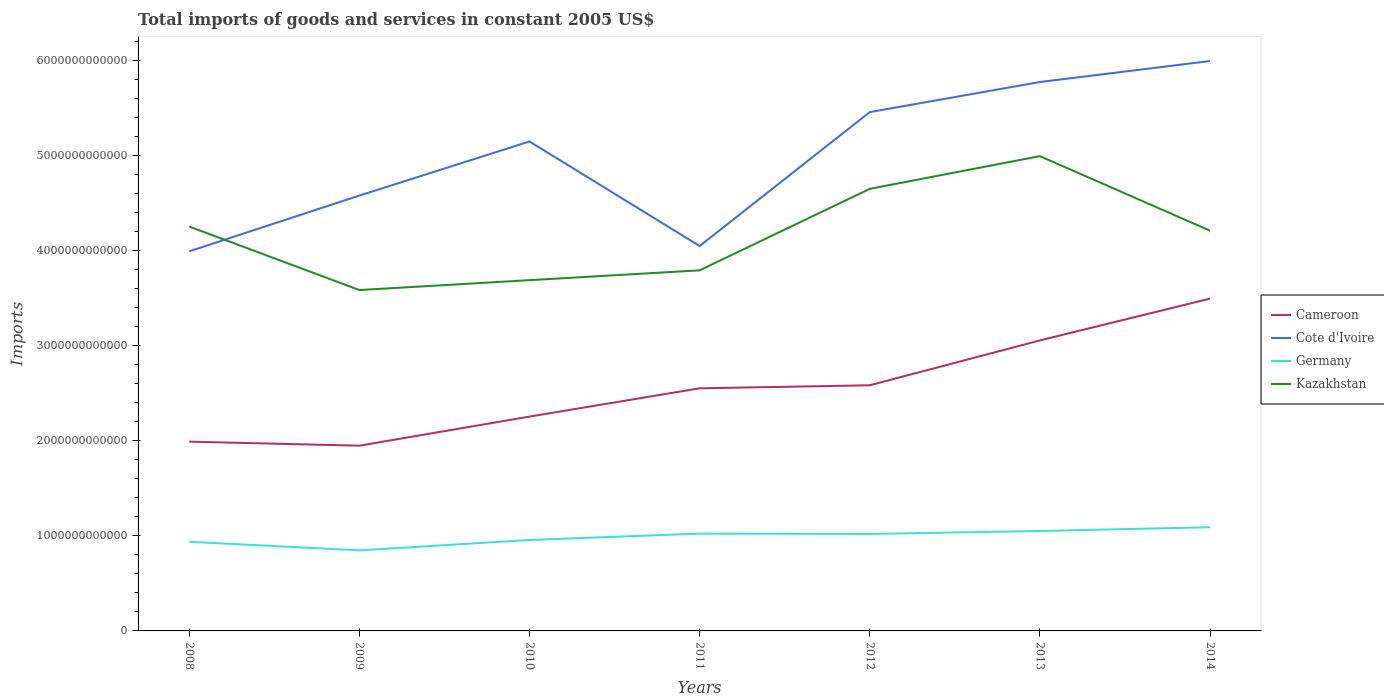Does the line corresponding to Cameroon intersect with the line corresponding to Germany?
Ensure brevity in your answer.  No. Across all years, what is the maximum total imports of goods and services in Kazakhstan?
Keep it short and to the point. 3.58e+12. In which year was the total imports of goods and services in Germany maximum?
Provide a short and direct response. 2009. What is the total total imports of goods and services in Cameroon in the graph?
Your answer should be very brief. -4.39e+11. What is the difference between the highest and the second highest total imports of goods and services in Cameroon?
Provide a succinct answer. 1.55e+12. How many years are there in the graph?
Your answer should be very brief. 7. What is the difference between two consecutive major ticks on the Y-axis?
Keep it short and to the point. 1.00e+12. Are the values on the major ticks of Y-axis written in scientific E-notation?
Your answer should be very brief. No. Does the graph contain any zero values?
Keep it short and to the point. No. Where does the legend appear in the graph?
Your answer should be very brief. Center right. How many legend labels are there?
Your answer should be compact. 4. What is the title of the graph?
Provide a succinct answer. Total imports of goods and services in constant 2005 US$. What is the label or title of the Y-axis?
Offer a terse response. Imports. What is the Imports in Cameroon in 2008?
Your response must be concise. 1.99e+12. What is the Imports in Cote d'Ivoire in 2008?
Offer a terse response. 3.99e+12. What is the Imports in Germany in 2008?
Provide a short and direct response. 9.37e+11. What is the Imports in Kazakhstan in 2008?
Keep it short and to the point. 4.25e+12. What is the Imports in Cameroon in 2009?
Your response must be concise. 1.95e+12. What is the Imports of Cote d'Ivoire in 2009?
Provide a succinct answer. 4.58e+12. What is the Imports of Germany in 2009?
Offer a very short reply. 8.47e+11. What is the Imports in Kazakhstan in 2009?
Ensure brevity in your answer.  3.58e+12. What is the Imports in Cameroon in 2010?
Provide a short and direct response. 2.25e+12. What is the Imports in Cote d'Ivoire in 2010?
Your response must be concise. 5.15e+12. What is the Imports in Germany in 2010?
Your answer should be compact. 9.56e+11. What is the Imports of Kazakhstan in 2010?
Provide a succinct answer. 3.69e+12. What is the Imports in Cameroon in 2011?
Keep it short and to the point. 2.55e+12. What is the Imports of Cote d'Ivoire in 2011?
Make the answer very short. 4.05e+12. What is the Imports in Germany in 2011?
Keep it short and to the point. 1.02e+12. What is the Imports in Kazakhstan in 2011?
Your response must be concise. 3.79e+12. What is the Imports of Cameroon in 2012?
Your answer should be very brief. 2.58e+12. What is the Imports in Cote d'Ivoire in 2012?
Your response must be concise. 5.45e+12. What is the Imports in Germany in 2012?
Provide a succinct answer. 1.02e+12. What is the Imports of Kazakhstan in 2012?
Ensure brevity in your answer.  4.65e+12. What is the Imports in Cameroon in 2013?
Your answer should be compact. 3.05e+12. What is the Imports in Cote d'Ivoire in 2013?
Make the answer very short. 5.77e+12. What is the Imports of Germany in 2013?
Your answer should be very brief. 1.05e+12. What is the Imports in Kazakhstan in 2013?
Provide a short and direct response. 4.99e+12. What is the Imports of Cameroon in 2014?
Provide a succinct answer. 3.49e+12. What is the Imports of Cote d'Ivoire in 2014?
Ensure brevity in your answer.  5.99e+12. What is the Imports of Germany in 2014?
Your answer should be compact. 1.09e+12. What is the Imports in Kazakhstan in 2014?
Provide a short and direct response. 4.21e+12. Across all years, what is the maximum Imports in Cameroon?
Provide a short and direct response. 3.49e+12. Across all years, what is the maximum Imports of Cote d'Ivoire?
Give a very brief answer. 5.99e+12. Across all years, what is the maximum Imports in Germany?
Your answer should be compact. 1.09e+12. Across all years, what is the maximum Imports in Kazakhstan?
Provide a succinct answer. 4.99e+12. Across all years, what is the minimum Imports of Cameroon?
Offer a very short reply. 1.95e+12. Across all years, what is the minimum Imports of Cote d'Ivoire?
Offer a very short reply. 3.99e+12. Across all years, what is the minimum Imports of Germany?
Make the answer very short. 8.47e+11. Across all years, what is the minimum Imports in Kazakhstan?
Your answer should be very brief. 3.58e+12. What is the total Imports in Cameroon in the graph?
Give a very brief answer. 1.79e+13. What is the total Imports of Cote d'Ivoire in the graph?
Provide a short and direct response. 3.50e+13. What is the total Imports in Germany in the graph?
Keep it short and to the point. 6.92e+12. What is the total Imports of Kazakhstan in the graph?
Give a very brief answer. 2.92e+13. What is the difference between the Imports of Cameroon in 2008 and that in 2009?
Provide a succinct answer. 4.22e+1. What is the difference between the Imports in Cote d'Ivoire in 2008 and that in 2009?
Keep it short and to the point. -5.86e+11. What is the difference between the Imports in Germany in 2008 and that in 2009?
Make the answer very short. 9.00e+1. What is the difference between the Imports of Kazakhstan in 2008 and that in 2009?
Your answer should be compact. 6.67e+11. What is the difference between the Imports in Cameroon in 2008 and that in 2010?
Provide a short and direct response. -2.63e+11. What is the difference between the Imports in Cote d'Ivoire in 2008 and that in 2010?
Your answer should be very brief. -1.15e+12. What is the difference between the Imports in Germany in 2008 and that in 2010?
Make the answer very short. -1.89e+1. What is the difference between the Imports in Kazakhstan in 2008 and that in 2010?
Keep it short and to the point. 5.63e+11. What is the difference between the Imports of Cameroon in 2008 and that in 2011?
Provide a short and direct response. -5.61e+11. What is the difference between the Imports in Cote d'Ivoire in 2008 and that in 2011?
Provide a succinct answer. -5.56e+1. What is the difference between the Imports of Germany in 2008 and that in 2011?
Ensure brevity in your answer.  -8.60e+1. What is the difference between the Imports of Kazakhstan in 2008 and that in 2011?
Your response must be concise. 4.60e+11. What is the difference between the Imports in Cameroon in 2008 and that in 2012?
Your answer should be compact. -5.93e+11. What is the difference between the Imports in Cote d'Ivoire in 2008 and that in 2012?
Give a very brief answer. -1.46e+12. What is the difference between the Imports of Germany in 2008 and that in 2012?
Your answer should be very brief. -8.25e+1. What is the difference between the Imports of Kazakhstan in 2008 and that in 2012?
Offer a terse response. -3.96e+11. What is the difference between the Imports of Cameroon in 2008 and that in 2013?
Offer a terse response. -1.06e+12. What is the difference between the Imports in Cote d'Ivoire in 2008 and that in 2013?
Your answer should be very brief. -1.78e+12. What is the difference between the Imports in Germany in 2008 and that in 2013?
Make the answer very short. -1.14e+11. What is the difference between the Imports of Kazakhstan in 2008 and that in 2013?
Provide a succinct answer. -7.40e+11. What is the difference between the Imports in Cameroon in 2008 and that in 2014?
Provide a succinct answer. -1.50e+12. What is the difference between the Imports in Cote d'Ivoire in 2008 and that in 2014?
Your answer should be very brief. -2.00e+12. What is the difference between the Imports of Germany in 2008 and that in 2014?
Keep it short and to the point. -1.53e+11. What is the difference between the Imports of Kazakhstan in 2008 and that in 2014?
Your answer should be compact. 4.33e+1. What is the difference between the Imports in Cameroon in 2009 and that in 2010?
Your response must be concise. -3.06e+11. What is the difference between the Imports of Cote d'Ivoire in 2009 and that in 2010?
Provide a short and direct response. -5.69e+11. What is the difference between the Imports of Germany in 2009 and that in 2010?
Keep it short and to the point. -1.09e+11. What is the difference between the Imports of Kazakhstan in 2009 and that in 2010?
Offer a terse response. -1.04e+11. What is the difference between the Imports in Cameroon in 2009 and that in 2011?
Your answer should be very brief. -6.03e+11. What is the difference between the Imports of Cote d'Ivoire in 2009 and that in 2011?
Your answer should be very brief. 5.30e+11. What is the difference between the Imports of Germany in 2009 and that in 2011?
Keep it short and to the point. -1.76e+11. What is the difference between the Imports of Kazakhstan in 2009 and that in 2011?
Offer a very short reply. -2.07e+11. What is the difference between the Imports in Cameroon in 2009 and that in 2012?
Your answer should be very brief. -6.35e+11. What is the difference between the Imports of Cote d'Ivoire in 2009 and that in 2012?
Give a very brief answer. -8.78e+11. What is the difference between the Imports in Germany in 2009 and that in 2012?
Offer a very short reply. -1.72e+11. What is the difference between the Imports of Kazakhstan in 2009 and that in 2012?
Offer a terse response. -1.06e+12. What is the difference between the Imports in Cameroon in 2009 and that in 2013?
Provide a short and direct response. -1.11e+12. What is the difference between the Imports of Cote d'Ivoire in 2009 and that in 2013?
Your answer should be compact. -1.19e+12. What is the difference between the Imports of Germany in 2009 and that in 2013?
Offer a terse response. -2.04e+11. What is the difference between the Imports of Kazakhstan in 2009 and that in 2013?
Your answer should be compact. -1.41e+12. What is the difference between the Imports of Cameroon in 2009 and that in 2014?
Give a very brief answer. -1.55e+12. What is the difference between the Imports of Cote d'Ivoire in 2009 and that in 2014?
Your answer should be compact. -1.41e+12. What is the difference between the Imports of Germany in 2009 and that in 2014?
Your answer should be compact. -2.43e+11. What is the difference between the Imports of Kazakhstan in 2009 and that in 2014?
Give a very brief answer. -6.24e+11. What is the difference between the Imports in Cameroon in 2010 and that in 2011?
Keep it short and to the point. -2.97e+11. What is the difference between the Imports in Cote d'Ivoire in 2010 and that in 2011?
Provide a short and direct response. 1.10e+12. What is the difference between the Imports of Germany in 2010 and that in 2011?
Ensure brevity in your answer.  -6.71e+1. What is the difference between the Imports of Kazakhstan in 2010 and that in 2011?
Your answer should be very brief. -1.03e+11. What is the difference between the Imports in Cameroon in 2010 and that in 2012?
Ensure brevity in your answer.  -3.29e+11. What is the difference between the Imports of Cote d'Ivoire in 2010 and that in 2012?
Keep it short and to the point. -3.09e+11. What is the difference between the Imports of Germany in 2010 and that in 2012?
Provide a succinct answer. -6.36e+1. What is the difference between the Imports in Kazakhstan in 2010 and that in 2012?
Your answer should be very brief. -9.60e+11. What is the difference between the Imports in Cameroon in 2010 and that in 2013?
Your answer should be very brief. -8.01e+11. What is the difference between the Imports in Cote d'Ivoire in 2010 and that in 2013?
Offer a terse response. -6.25e+11. What is the difference between the Imports in Germany in 2010 and that in 2013?
Ensure brevity in your answer.  -9.48e+1. What is the difference between the Imports in Kazakhstan in 2010 and that in 2013?
Your answer should be very brief. -1.30e+12. What is the difference between the Imports of Cameroon in 2010 and that in 2014?
Give a very brief answer. -1.24e+12. What is the difference between the Imports of Cote d'Ivoire in 2010 and that in 2014?
Your answer should be very brief. -8.46e+11. What is the difference between the Imports of Germany in 2010 and that in 2014?
Offer a very short reply. -1.34e+11. What is the difference between the Imports in Kazakhstan in 2010 and that in 2014?
Make the answer very short. -5.20e+11. What is the difference between the Imports of Cameroon in 2011 and that in 2012?
Your answer should be compact. -3.18e+1. What is the difference between the Imports in Cote d'Ivoire in 2011 and that in 2012?
Give a very brief answer. -1.41e+12. What is the difference between the Imports in Germany in 2011 and that in 2012?
Provide a short and direct response. 3.54e+09. What is the difference between the Imports in Kazakhstan in 2011 and that in 2012?
Offer a terse response. -8.57e+11. What is the difference between the Imports in Cameroon in 2011 and that in 2013?
Make the answer very short. -5.04e+11. What is the difference between the Imports in Cote d'Ivoire in 2011 and that in 2013?
Make the answer very short. -1.72e+12. What is the difference between the Imports of Germany in 2011 and that in 2013?
Your response must be concise. -2.77e+1. What is the difference between the Imports in Kazakhstan in 2011 and that in 2013?
Offer a very short reply. -1.20e+12. What is the difference between the Imports of Cameroon in 2011 and that in 2014?
Your answer should be compact. -9.43e+11. What is the difference between the Imports in Cote d'Ivoire in 2011 and that in 2014?
Provide a short and direct response. -1.94e+12. What is the difference between the Imports of Germany in 2011 and that in 2014?
Make the answer very short. -6.69e+1. What is the difference between the Imports in Kazakhstan in 2011 and that in 2014?
Offer a very short reply. -4.17e+11. What is the difference between the Imports of Cameroon in 2012 and that in 2013?
Give a very brief answer. -4.72e+11. What is the difference between the Imports in Cote d'Ivoire in 2012 and that in 2013?
Give a very brief answer. -3.16e+11. What is the difference between the Imports of Germany in 2012 and that in 2013?
Your answer should be compact. -3.13e+1. What is the difference between the Imports in Kazakhstan in 2012 and that in 2013?
Your response must be concise. -3.44e+11. What is the difference between the Imports of Cameroon in 2012 and that in 2014?
Provide a succinct answer. -9.11e+11. What is the difference between the Imports in Cote d'Ivoire in 2012 and that in 2014?
Provide a succinct answer. -5.37e+11. What is the difference between the Imports in Germany in 2012 and that in 2014?
Keep it short and to the point. -7.05e+1. What is the difference between the Imports of Kazakhstan in 2012 and that in 2014?
Offer a very short reply. 4.40e+11. What is the difference between the Imports of Cameroon in 2013 and that in 2014?
Offer a terse response. -4.39e+11. What is the difference between the Imports of Cote d'Ivoire in 2013 and that in 2014?
Ensure brevity in your answer.  -2.21e+11. What is the difference between the Imports of Germany in 2013 and that in 2014?
Make the answer very short. -3.92e+1. What is the difference between the Imports of Kazakhstan in 2013 and that in 2014?
Make the answer very short. 7.84e+11. What is the difference between the Imports in Cameroon in 2008 and the Imports in Cote d'Ivoire in 2009?
Offer a terse response. -2.59e+12. What is the difference between the Imports in Cameroon in 2008 and the Imports in Germany in 2009?
Your answer should be very brief. 1.14e+12. What is the difference between the Imports of Cameroon in 2008 and the Imports of Kazakhstan in 2009?
Provide a short and direct response. -1.59e+12. What is the difference between the Imports of Cote d'Ivoire in 2008 and the Imports of Germany in 2009?
Your answer should be compact. 3.14e+12. What is the difference between the Imports in Cote d'Ivoire in 2008 and the Imports in Kazakhstan in 2009?
Keep it short and to the point. 4.07e+11. What is the difference between the Imports of Germany in 2008 and the Imports of Kazakhstan in 2009?
Your answer should be very brief. -2.65e+12. What is the difference between the Imports of Cameroon in 2008 and the Imports of Cote d'Ivoire in 2010?
Keep it short and to the point. -3.16e+12. What is the difference between the Imports in Cameroon in 2008 and the Imports in Germany in 2010?
Your answer should be compact. 1.03e+12. What is the difference between the Imports of Cameroon in 2008 and the Imports of Kazakhstan in 2010?
Give a very brief answer. -1.70e+12. What is the difference between the Imports of Cote d'Ivoire in 2008 and the Imports of Germany in 2010?
Your answer should be compact. 3.03e+12. What is the difference between the Imports in Cote d'Ivoire in 2008 and the Imports in Kazakhstan in 2010?
Keep it short and to the point. 3.03e+11. What is the difference between the Imports of Germany in 2008 and the Imports of Kazakhstan in 2010?
Ensure brevity in your answer.  -2.75e+12. What is the difference between the Imports of Cameroon in 2008 and the Imports of Cote d'Ivoire in 2011?
Ensure brevity in your answer.  -2.06e+12. What is the difference between the Imports in Cameroon in 2008 and the Imports in Germany in 2011?
Give a very brief answer. 9.67e+11. What is the difference between the Imports of Cameroon in 2008 and the Imports of Kazakhstan in 2011?
Your answer should be very brief. -1.80e+12. What is the difference between the Imports in Cote d'Ivoire in 2008 and the Imports in Germany in 2011?
Your answer should be very brief. 2.97e+12. What is the difference between the Imports of Cote d'Ivoire in 2008 and the Imports of Kazakhstan in 2011?
Make the answer very short. 2.00e+11. What is the difference between the Imports in Germany in 2008 and the Imports in Kazakhstan in 2011?
Your answer should be compact. -2.85e+12. What is the difference between the Imports in Cameroon in 2008 and the Imports in Cote d'Ivoire in 2012?
Keep it short and to the point. -3.46e+12. What is the difference between the Imports in Cameroon in 2008 and the Imports in Germany in 2012?
Your response must be concise. 9.70e+11. What is the difference between the Imports in Cameroon in 2008 and the Imports in Kazakhstan in 2012?
Provide a succinct answer. -2.66e+12. What is the difference between the Imports in Cote d'Ivoire in 2008 and the Imports in Germany in 2012?
Provide a succinct answer. 2.97e+12. What is the difference between the Imports of Cote d'Ivoire in 2008 and the Imports of Kazakhstan in 2012?
Offer a very short reply. -6.57e+11. What is the difference between the Imports in Germany in 2008 and the Imports in Kazakhstan in 2012?
Ensure brevity in your answer.  -3.71e+12. What is the difference between the Imports in Cameroon in 2008 and the Imports in Cote d'Ivoire in 2013?
Your response must be concise. -3.78e+12. What is the difference between the Imports of Cameroon in 2008 and the Imports of Germany in 2013?
Make the answer very short. 9.39e+11. What is the difference between the Imports of Cameroon in 2008 and the Imports of Kazakhstan in 2013?
Your response must be concise. -3.00e+12. What is the difference between the Imports of Cote d'Ivoire in 2008 and the Imports of Germany in 2013?
Give a very brief answer. 2.94e+12. What is the difference between the Imports in Cote d'Ivoire in 2008 and the Imports in Kazakhstan in 2013?
Your response must be concise. -1.00e+12. What is the difference between the Imports of Germany in 2008 and the Imports of Kazakhstan in 2013?
Your answer should be very brief. -4.05e+12. What is the difference between the Imports of Cameroon in 2008 and the Imports of Cote d'Ivoire in 2014?
Keep it short and to the point. -4.00e+12. What is the difference between the Imports of Cameroon in 2008 and the Imports of Germany in 2014?
Keep it short and to the point. 9.00e+11. What is the difference between the Imports in Cameroon in 2008 and the Imports in Kazakhstan in 2014?
Your answer should be very brief. -2.22e+12. What is the difference between the Imports of Cote d'Ivoire in 2008 and the Imports of Germany in 2014?
Provide a succinct answer. 2.90e+12. What is the difference between the Imports in Cote d'Ivoire in 2008 and the Imports in Kazakhstan in 2014?
Offer a terse response. -2.17e+11. What is the difference between the Imports of Germany in 2008 and the Imports of Kazakhstan in 2014?
Your response must be concise. -3.27e+12. What is the difference between the Imports of Cameroon in 2009 and the Imports of Cote d'Ivoire in 2010?
Give a very brief answer. -3.20e+12. What is the difference between the Imports of Cameroon in 2009 and the Imports of Germany in 2010?
Provide a succinct answer. 9.92e+11. What is the difference between the Imports of Cameroon in 2009 and the Imports of Kazakhstan in 2010?
Provide a succinct answer. -1.74e+12. What is the difference between the Imports in Cote d'Ivoire in 2009 and the Imports in Germany in 2010?
Offer a very short reply. 3.62e+12. What is the difference between the Imports in Cote d'Ivoire in 2009 and the Imports in Kazakhstan in 2010?
Your response must be concise. 8.89e+11. What is the difference between the Imports of Germany in 2009 and the Imports of Kazakhstan in 2010?
Offer a very short reply. -2.84e+12. What is the difference between the Imports in Cameroon in 2009 and the Imports in Cote d'Ivoire in 2011?
Make the answer very short. -2.10e+12. What is the difference between the Imports of Cameroon in 2009 and the Imports of Germany in 2011?
Your response must be concise. 9.24e+11. What is the difference between the Imports of Cameroon in 2009 and the Imports of Kazakhstan in 2011?
Provide a short and direct response. -1.84e+12. What is the difference between the Imports of Cote d'Ivoire in 2009 and the Imports of Germany in 2011?
Make the answer very short. 3.55e+12. What is the difference between the Imports in Cote d'Ivoire in 2009 and the Imports in Kazakhstan in 2011?
Provide a succinct answer. 7.86e+11. What is the difference between the Imports in Germany in 2009 and the Imports in Kazakhstan in 2011?
Your answer should be very brief. -2.94e+12. What is the difference between the Imports in Cameroon in 2009 and the Imports in Cote d'Ivoire in 2012?
Make the answer very short. -3.51e+12. What is the difference between the Imports of Cameroon in 2009 and the Imports of Germany in 2012?
Your answer should be very brief. 9.28e+11. What is the difference between the Imports of Cameroon in 2009 and the Imports of Kazakhstan in 2012?
Your answer should be very brief. -2.70e+12. What is the difference between the Imports of Cote d'Ivoire in 2009 and the Imports of Germany in 2012?
Offer a terse response. 3.56e+12. What is the difference between the Imports in Cote d'Ivoire in 2009 and the Imports in Kazakhstan in 2012?
Provide a short and direct response. -7.08e+1. What is the difference between the Imports of Germany in 2009 and the Imports of Kazakhstan in 2012?
Keep it short and to the point. -3.80e+12. What is the difference between the Imports of Cameroon in 2009 and the Imports of Cote d'Ivoire in 2013?
Provide a short and direct response. -3.82e+12. What is the difference between the Imports of Cameroon in 2009 and the Imports of Germany in 2013?
Provide a succinct answer. 8.97e+11. What is the difference between the Imports of Cameroon in 2009 and the Imports of Kazakhstan in 2013?
Your answer should be compact. -3.04e+12. What is the difference between the Imports in Cote d'Ivoire in 2009 and the Imports in Germany in 2013?
Your response must be concise. 3.53e+12. What is the difference between the Imports in Cote d'Ivoire in 2009 and the Imports in Kazakhstan in 2013?
Offer a terse response. -4.15e+11. What is the difference between the Imports in Germany in 2009 and the Imports in Kazakhstan in 2013?
Provide a succinct answer. -4.14e+12. What is the difference between the Imports of Cameroon in 2009 and the Imports of Cote d'Ivoire in 2014?
Your response must be concise. -4.04e+12. What is the difference between the Imports in Cameroon in 2009 and the Imports in Germany in 2014?
Your response must be concise. 8.58e+11. What is the difference between the Imports in Cameroon in 2009 and the Imports in Kazakhstan in 2014?
Offer a terse response. -2.26e+12. What is the difference between the Imports of Cote d'Ivoire in 2009 and the Imports of Germany in 2014?
Keep it short and to the point. 3.49e+12. What is the difference between the Imports in Cote d'Ivoire in 2009 and the Imports in Kazakhstan in 2014?
Your answer should be very brief. 3.69e+11. What is the difference between the Imports of Germany in 2009 and the Imports of Kazakhstan in 2014?
Provide a succinct answer. -3.36e+12. What is the difference between the Imports in Cameroon in 2010 and the Imports in Cote d'Ivoire in 2011?
Provide a succinct answer. -1.79e+12. What is the difference between the Imports in Cameroon in 2010 and the Imports in Germany in 2011?
Your answer should be very brief. 1.23e+12. What is the difference between the Imports in Cameroon in 2010 and the Imports in Kazakhstan in 2011?
Offer a very short reply. -1.54e+12. What is the difference between the Imports in Cote d'Ivoire in 2010 and the Imports in Germany in 2011?
Your answer should be compact. 4.12e+12. What is the difference between the Imports in Cote d'Ivoire in 2010 and the Imports in Kazakhstan in 2011?
Your response must be concise. 1.35e+12. What is the difference between the Imports of Germany in 2010 and the Imports of Kazakhstan in 2011?
Provide a succinct answer. -2.83e+12. What is the difference between the Imports in Cameroon in 2010 and the Imports in Cote d'Ivoire in 2012?
Give a very brief answer. -3.20e+12. What is the difference between the Imports of Cameroon in 2010 and the Imports of Germany in 2012?
Give a very brief answer. 1.23e+12. What is the difference between the Imports in Cameroon in 2010 and the Imports in Kazakhstan in 2012?
Your answer should be very brief. -2.39e+12. What is the difference between the Imports in Cote d'Ivoire in 2010 and the Imports in Germany in 2012?
Provide a short and direct response. 4.13e+12. What is the difference between the Imports in Cote d'Ivoire in 2010 and the Imports in Kazakhstan in 2012?
Your answer should be very brief. 4.98e+11. What is the difference between the Imports of Germany in 2010 and the Imports of Kazakhstan in 2012?
Provide a succinct answer. -3.69e+12. What is the difference between the Imports of Cameroon in 2010 and the Imports of Cote d'Ivoire in 2013?
Keep it short and to the point. -3.52e+12. What is the difference between the Imports of Cameroon in 2010 and the Imports of Germany in 2013?
Keep it short and to the point. 1.20e+12. What is the difference between the Imports in Cameroon in 2010 and the Imports in Kazakhstan in 2013?
Ensure brevity in your answer.  -2.74e+12. What is the difference between the Imports in Cote d'Ivoire in 2010 and the Imports in Germany in 2013?
Keep it short and to the point. 4.09e+12. What is the difference between the Imports in Cote d'Ivoire in 2010 and the Imports in Kazakhstan in 2013?
Your answer should be very brief. 1.54e+11. What is the difference between the Imports in Germany in 2010 and the Imports in Kazakhstan in 2013?
Give a very brief answer. -4.04e+12. What is the difference between the Imports in Cameroon in 2010 and the Imports in Cote d'Ivoire in 2014?
Keep it short and to the point. -3.74e+12. What is the difference between the Imports in Cameroon in 2010 and the Imports in Germany in 2014?
Provide a short and direct response. 1.16e+12. What is the difference between the Imports in Cameroon in 2010 and the Imports in Kazakhstan in 2014?
Ensure brevity in your answer.  -1.95e+12. What is the difference between the Imports in Cote d'Ivoire in 2010 and the Imports in Germany in 2014?
Provide a short and direct response. 4.06e+12. What is the difference between the Imports of Cote d'Ivoire in 2010 and the Imports of Kazakhstan in 2014?
Keep it short and to the point. 9.38e+11. What is the difference between the Imports of Germany in 2010 and the Imports of Kazakhstan in 2014?
Your answer should be very brief. -3.25e+12. What is the difference between the Imports of Cameroon in 2011 and the Imports of Cote d'Ivoire in 2012?
Provide a short and direct response. -2.90e+12. What is the difference between the Imports of Cameroon in 2011 and the Imports of Germany in 2012?
Make the answer very short. 1.53e+12. What is the difference between the Imports of Cameroon in 2011 and the Imports of Kazakhstan in 2012?
Offer a terse response. -2.10e+12. What is the difference between the Imports in Cote d'Ivoire in 2011 and the Imports in Germany in 2012?
Offer a terse response. 3.03e+12. What is the difference between the Imports of Cote d'Ivoire in 2011 and the Imports of Kazakhstan in 2012?
Provide a short and direct response. -6.01e+11. What is the difference between the Imports in Germany in 2011 and the Imports in Kazakhstan in 2012?
Give a very brief answer. -3.62e+12. What is the difference between the Imports of Cameroon in 2011 and the Imports of Cote d'Ivoire in 2013?
Provide a succinct answer. -3.22e+12. What is the difference between the Imports of Cameroon in 2011 and the Imports of Germany in 2013?
Offer a very short reply. 1.50e+12. What is the difference between the Imports in Cameroon in 2011 and the Imports in Kazakhstan in 2013?
Provide a short and direct response. -2.44e+12. What is the difference between the Imports of Cote d'Ivoire in 2011 and the Imports of Germany in 2013?
Give a very brief answer. 3.00e+12. What is the difference between the Imports in Cote d'Ivoire in 2011 and the Imports in Kazakhstan in 2013?
Your answer should be compact. -9.45e+11. What is the difference between the Imports in Germany in 2011 and the Imports in Kazakhstan in 2013?
Ensure brevity in your answer.  -3.97e+12. What is the difference between the Imports of Cameroon in 2011 and the Imports of Cote d'Ivoire in 2014?
Your answer should be compact. -3.44e+12. What is the difference between the Imports of Cameroon in 2011 and the Imports of Germany in 2014?
Give a very brief answer. 1.46e+12. What is the difference between the Imports in Cameroon in 2011 and the Imports in Kazakhstan in 2014?
Keep it short and to the point. -1.66e+12. What is the difference between the Imports in Cote d'Ivoire in 2011 and the Imports in Germany in 2014?
Your answer should be compact. 2.96e+12. What is the difference between the Imports in Cote d'Ivoire in 2011 and the Imports in Kazakhstan in 2014?
Make the answer very short. -1.61e+11. What is the difference between the Imports of Germany in 2011 and the Imports of Kazakhstan in 2014?
Provide a short and direct response. -3.18e+12. What is the difference between the Imports in Cameroon in 2012 and the Imports in Cote d'Ivoire in 2013?
Provide a short and direct response. -3.19e+12. What is the difference between the Imports of Cameroon in 2012 and the Imports of Germany in 2013?
Offer a very short reply. 1.53e+12. What is the difference between the Imports of Cameroon in 2012 and the Imports of Kazakhstan in 2013?
Make the answer very short. -2.41e+12. What is the difference between the Imports of Cote d'Ivoire in 2012 and the Imports of Germany in 2013?
Provide a succinct answer. 4.40e+12. What is the difference between the Imports of Cote d'Ivoire in 2012 and the Imports of Kazakhstan in 2013?
Your answer should be very brief. 4.63e+11. What is the difference between the Imports in Germany in 2012 and the Imports in Kazakhstan in 2013?
Offer a terse response. -3.97e+12. What is the difference between the Imports of Cameroon in 2012 and the Imports of Cote d'Ivoire in 2014?
Ensure brevity in your answer.  -3.41e+12. What is the difference between the Imports of Cameroon in 2012 and the Imports of Germany in 2014?
Offer a terse response. 1.49e+12. What is the difference between the Imports in Cameroon in 2012 and the Imports in Kazakhstan in 2014?
Ensure brevity in your answer.  -1.63e+12. What is the difference between the Imports in Cote d'Ivoire in 2012 and the Imports in Germany in 2014?
Offer a terse response. 4.36e+12. What is the difference between the Imports in Cote d'Ivoire in 2012 and the Imports in Kazakhstan in 2014?
Provide a succinct answer. 1.25e+12. What is the difference between the Imports in Germany in 2012 and the Imports in Kazakhstan in 2014?
Make the answer very short. -3.19e+12. What is the difference between the Imports in Cameroon in 2013 and the Imports in Cote d'Ivoire in 2014?
Provide a short and direct response. -2.94e+12. What is the difference between the Imports of Cameroon in 2013 and the Imports of Germany in 2014?
Give a very brief answer. 1.96e+12. What is the difference between the Imports of Cameroon in 2013 and the Imports of Kazakhstan in 2014?
Ensure brevity in your answer.  -1.15e+12. What is the difference between the Imports of Cote d'Ivoire in 2013 and the Imports of Germany in 2014?
Make the answer very short. 4.68e+12. What is the difference between the Imports of Cote d'Ivoire in 2013 and the Imports of Kazakhstan in 2014?
Ensure brevity in your answer.  1.56e+12. What is the difference between the Imports in Germany in 2013 and the Imports in Kazakhstan in 2014?
Your response must be concise. -3.16e+12. What is the average Imports in Cameroon per year?
Keep it short and to the point. 2.55e+12. What is the average Imports in Cote d'Ivoire per year?
Offer a very short reply. 5.00e+12. What is the average Imports of Germany per year?
Offer a very short reply. 9.89e+11. What is the average Imports in Kazakhstan per year?
Your answer should be compact. 4.17e+12. In the year 2008, what is the difference between the Imports of Cameroon and Imports of Cote d'Ivoire?
Give a very brief answer. -2.00e+12. In the year 2008, what is the difference between the Imports of Cameroon and Imports of Germany?
Your answer should be compact. 1.05e+12. In the year 2008, what is the difference between the Imports of Cameroon and Imports of Kazakhstan?
Provide a succinct answer. -2.26e+12. In the year 2008, what is the difference between the Imports in Cote d'Ivoire and Imports in Germany?
Your answer should be very brief. 3.05e+12. In the year 2008, what is the difference between the Imports in Cote d'Ivoire and Imports in Kazakhstan?
Make the answer very short. -2.60e+11. In the year 2008, what is the difference between the Imports in Germany and Imports in Kazakhstan?
Keep it short and to the point. -3.31e+12. In the year 2009, what is the difference between the Imports of Cameroon and Imports of Cote d'Ivoire?
Ensure brevity in your answer.  -2.63e+12. In the year 2009, what is the difference between the Imports in Cameroon and Imports in Germany?
Make the answer very short. 1.10e+12. In the year 2009, what is the difference between the Imports of Cameroon and Imports of Kazakhstan?
Ensure brevity in your answer.  -1.64e+12. In the year 2009, what is the difference between the Imports in Cote d'Ivoire and Imports in Germany?
Offer a terse response. 3.73e+12. In the year 2009, what is the difference between the Imports in Cote d'Ivoire and Imports in Kazakhstan?
Your answer should be compact. 9.93e+11. In the year 2009, what is the difference between the Imports in Germany and Imports in Kazakhstan?
Provide a short and direct response. -2.74e+12. In the year 2010, what is the difference between the Imports in Cameroon and Imports in Cote d'Ivoire?
Your answer should be compact. -2.89e+12. In the year 2010, what is the difference between the Imports of Cameroon and Imports of Germany?
Provide a succinct answer. 1.30e+12. In the year 2010, what is the difference between the Imports in Cameroon and Imports in Kazakhstan?
Your answer should be very brief. -1.43e+12. In the year 2010, what is the difference between the Imports in Cote d'Ivoire and Imports in Germany?
Your response must be concise. 4.19e+12. In the year 2010, what is the difference between the Imports in Cote d'Ivoire and Imports in Kazakhstan?
Ensure brevity in your answer.  1.46e+12. In the year 2010, what is the difference between the Imports in Germany and Imports in Kazakhstan?
Your answer should be very brief. -2.73e+12. In the year 2011, what is the difference between the Imports in Cameroon and Imports in Cote d'Ivoire?
Give a very brief answer. -1.50e+12. In the year 2011, what is the difference between the Imports in Cameroon and Imports in Germany?
Keep it short and to the point. 1.53e+12. In the year 2011, what is the difference between the Imports of Cameroon and Imports of Kazakhstan?
Your answer should be compact. -1.24e+12. In the year 2011, what is the difference between the Imports in Cote d'Ivoire and Imports in Germany?
Your answer should be very brief. 3.02e+12. In the year 2011, what is the difference between the Imports of Cote d'Ivoire and Imports of Kazakhstan?
Your response must be concise. 2.56e+11. In the year 2011, what is the difference between the Imports in Germany and Imports in Kazakhstan?
Your answer should be very brief. -2.77e+12. In the year 2012, what is the difference between the Imports in Cameroon and Imports in Cote d'Ivoire?
Keep it short and to the point. -2.87e+12. In the year 2012, what is the difference between the Imports in Cameroon and Imports in Germany?
Your response must be concise. 1.56e+12. In the year 2012, what is the difference between the Imports of Cameroon and Imports of Kazakhstan?
Your answer should be very brief. -2.07e+12. In the year 2012, what is the difference between the Imports in Cote d'Ivoire and Imports in Germany?
Your answer should be compact. 4.43e+12. In the year 2012, what is the difference between the Imports in Cote d'Ivoire and Imports in Kazakhstan?
Provide a short and direct response. 8.07e+11. In the year 2012, what is the difference between the Imports of Germany and Imports of Kazakhstan?
Offer a terse response. -3.63e+12. In the year 2013, what is the difference between the Imports in Cameroon and Imports in Cote d'Ivoire?
Provide a succinct answer. -2.72e+12. In the year 2013, what is the difference between the Imports of Cameroon and Imports of Germany?
Ensure brevity in your answer.  2.00e+12. In the year 2013, what is the difference between the Imports of Cameroon and Imports of Kazakhstan?
Offer a very short reply. -1.94e+12. In the year 2013, what is the difference between the Imports of Cote d'Ivoire and Imports of Germany?
Provide a short and direct response. 4.72e+12. In the year 2013, what is the difference between the Imports in Cote d'Ivoire and Imports in Kazakhstan?
Ensure brevity in your answer.  7.79e+11. In the year 2013, what is the difference between the Imports of Germany and Imports of Kazakhstan?
Your answer should be compact. -3.94e+12. In the year 2014, what is the difference between the Imports in Cameroon and Imports in Cote d'Ivoire?
Provide a succinct answer. -2.50e+12. In the year 2014, what is the difference between the Imports of Cameroon and Imports of Germany?
Ensure brevity in your answer.  2.40e+12. In the year 2014, what is the difference between the Imports of Cameroon and Imports of Kazakhstan?
Offer a terse response. -7.14e+11. In the year 2014, what is the difference between the Imports of Cote d'Ivoire and Imports of Germany?
Offer a very short reply. 4.90e+12. In the year 2014, what is the difference between the Imports of Cote d'Ivoire and Imports of Kazakhstan?
Your answer should be very brief. 1.78e+12. In the year 2014, what is the difference between the Imports in Germany and Imports in Kazakhstan?
Ensure brevity in your answer.  -3.12e+12. What is the ratio of the Imports of Cameroon in 2008 to that in 2009?
Provide a short and direct response. 1.02. What is the ratio of the Imports of Cote d'Ivoire in 2008 to that in 2009?
Make the answer very short. 0.87. What is the ratio of the Imports in Germany in 2008 to that in 2009?
Keep it short and to the point. 1.11. What is the ratio of the Imports of Kazakhstan in 2008 to that in 2009?
Offer a very short reply. 1.19. What is the ratio of the Imports in Cameroon in 2008 to that in 2010?
Make the answer very short. 0.88. What is the ratio of the Imports of Cote d'Ivoire in 2008 to that in 2010?
Your answer should be compact. 0.78. What is the ratio of the Imports of Germany in 2008 to that in 2010?
Provide a succinct answer. 0.98. What is the ratio of the Imports in Kazakhstan in 2008 to that in 2010?
Offer a terse response. 1.15. What is the ratio of the Imports in Cameroon in 2008 to that in 2011?
Make the answer very short. 0.78. What is the ratio of the Imports of Cote d'Ivoire in 2008 to that in 2011?
Offer a terse response. 0.99. What is the ratio of the Imports of Germany in 2008 to that in 2011?
Make the answer very short. 0.92. What is the ratio of the Imports of Kazakhstan in 2008 to that in 2011?
Make the answer very short. 1.12. What is the ratio of the Imports in Cameroon in 2008 to that in 2012?
Keep it short and to the point. 0.77. What is the ratio of the Imports of Cote d'Ivoire in 2008 to that in 2012?
Your answer should be very brief. 0.73. What is the ratio of the Imports of Germany in 2008 to that in 2012?
Offer a very short reply. 0.92. What is the ratio of the Imports in Kazakhstan in 2008 to that in 2012?
Your response must be concise. 0.91. What is the ratio of the Imports in Cameroon in 2008 to that in 2013?
Keep it short and to the point. 0.65. What is the ratio of the Imports of Cote d'Ivoire in 2008 to that in 2013?
Provide a short and direct response. 0.69. What is the ratio of the Imports in Germany in 2008 to that in 2013?
Provide a succinct answer. 0.89. What is the ratio of the Imports of Kazakhstan in 2008 to that in 2013?
Your answer should be very brief. 0.85. What is the ratio of the Imports of Cameroon in 2008 to that in 2014?
Provide a short and direct response. 0.57. What is the ratio of the Imports in Cote d'Ivoire in 2008 to that in 2014?
Your answer should be very brief. 0.67. What is the ratio of the Imports in Germany in 2008 to that in 2014?
Make the answer very short. 0.86. What is the ratio of the Imports of Kazakhstan in 2008 to that in 2014?
Offer a terse response. 1.01. What is the ratio of the Imports of Cameroon in 2009 to that in 2010?
Your answer should be compact. 0.86. What is the ratio of the Imports in Cote d'Ivoire in 2009 to that in 2010?
Provide a short and direct response. 0.89. What is the ratio of the Imports of Germany in 2009 to that in 2010?
Keep it short and to the point. 0.89. What is the ratio of the Imports of Kazakhstan in 2009 to that in 2010?
Offer a very short reply. 0.97. What is the ratio of the Imports of Cameroon in 2009 to that in 2011?
Provide a short and direct response. 0.76. What is the ratio of the Imports in Cote d'Ivoire in 2009 to that in 2011?
Offer a very short reply. 1.13. What is the ratio of the Imports of Germany in 2009 to that in 2011?
Ensure brevity in your answer.  0.83. What is the ratio of the Imports of Kazakhstan in 2009 to that in 2011?
Provide a succinct answer. 0.95. What is the ratio of the Imports of Cameroon in 2009 to that in 2012?
Ensure brevity in your answer.  0.75. What is the ratio of the Imports of Cote d'Ivoire in 2009 to that in 2012?
Ensure brevity in your answer.  0.84. What is the ratio of the Imports in Germany in 2009 to that in 2012?
Your answer should be very brief. 0.83. What is the ratio of the Imports in Kazakhstan in 2009 to that in 2012?
Make the answer very short. 0.77. What is the ratio of the Imports of Cameroon in 2009 to that in 2013?
Make the answer very short. 0.64. What is the ratio of the Imports in Cote d'Ivoire in 2009 to that in 2013?
Your response must be concise. 0.79. What is the ratio of the Imports of Germany in 2009 to that in 2013?
Offer a terse response. 0.81. What is the ratio of the Imports of Kazakhstan in 2009 to that in 2013?
Keep it short and to the point. 0.72. What is the ratio of the Imports of Cameroon in 2009 to that in 2014?
Your answer should be very brief. 0.56. What is the ratio of the Imports of Cote d'Ivoire in 2009 to that in 2014?
Offer a very short reply. 0.76. What is the ratio of the Imports in Germany in 2009 to that in 2014?
Your response must be concise. 0.78. What is the ratio of the Imports of Kazakhstan in 2009 to that in 2014?
Provide a short and direct response. 0.85. What is the ratio of the Imports of Cameroon in 2010 to that in 2011?
Your response must be concise. 0.88. What is the ratio of the Imports in Cote d'Ivoire in 2010 to that in 2011?
Your answer should be very brief. 1.27. What is the ratio of the Imports of Germany in 2010 to that in 2011?
Provide a short and direct response. 0.93. What is the ratio of the Imports in Kazakhstan in 2010 to that in 2011?
Your answer should be very brief. 0.97. What is the ratio of the Imports of Cameroon in 2010 to that in 2012?
Keep it short and to the point. 0.87. What is the ratio of the Imports of Cote d'Ivoire in 2010 to that in 2012?
Your answer should be very brief. 0.94. What is the ratio of the Imports of Germany in 2010 to that in 2012?
Your answer should be compact. 0.94. What is the ratio of the Imports of Kazakhstan in 2010 to that in 2012?
Provide a short and direct response. 0.79. What is the ratio of the Imports in Cameroon in 2010 to that in 2013?
Give a very brief answer. 0.74. What is the ratio of the Imports of Cote d'Ivoire in 2010 to that in 2013?
Offer a very short reply. 0.89. What is the ratio of the Imports in Germany in 2010 to that in 2013?
Your answer should be compact. 0.91. What is the ratio of the Imports of Kazakhstan in 2010 to that in 2013?
Keep it short and to the point. 0.74. What is the ratio of the Imports of Cameroon in 2010 to that in 2014?
Offer a very short reply. 0.65. What is the ratio of the Imports of Cote d'Ivoire in 2010 to that in 2014?
Provide a short and direct response. 0.86. What is the ratio of the Imports of Germany in 2010 to that in 2014?
Your response must be concise. 0.88. What is the ratio of the Imports in Kazakhstan in 2010 to that in 2014?
Provide a succinct answer. 0.88. What is the ratio of the Imports in Cameroon in 2011 to that in 2012?
Offer a terse response. 0.99. What is the ratio of the Imports of Cote d'Ivoire in 2011 to that in 2012?
Make the answer very short. 0.74. What is the ratio of the Imports of Germany in 2011 to that in 2012?
Provide a short and direct response. 1. What is the ratio of the Imports in Kazakhstan in 2011 to that in 2012?
Keep it short and to the point. 0.82. What is the ratio of the Imports in Cameroon in 2011 to that in 2013?
Provide a short and direct response. 0.84. What is the ratio of the Imports of Cote d'Ivoire in 2011 to that in 2013?
Ensure brevity in your answer.  0.7. What is the ratio of the Imports of Germany in 2011 to that in 2013?
Your response must be concise. 0.97. What is the ratio of the Imports in Kazakhstan in 2011 to that in 2013?
Give a very brief answer. 0.76. What is the ratio of the Imports in Cameroon in 2011 to that in 2014?
Offer a very short reply. 0.73. What is the ratio of the Imports in Cote d'Ivoire in 2011 to that in 2014?
Provide a succinct answer. 0.68. What is the ratio of the Imports in Germany in 2011 to that in 2014?
Provide a succinct answer. 0.94. What is the ratio of the Imports in Kazakhstan in 2011 to that in 2014?
Provide a succinct answer. 0.9. What is the ratio of the Imports in Cameroon in 2012 to that in 2013?
Provide a short and direct response. 0.85. What is the ratio of the Imports of Cote d'Ivoire in 2012 to that in 2013?
Offer a very short reply. 0.95. What is the ratio of the Imports of Germany in 2012 to that in 2013?
Provide a short and direct response. 0.97. What is the ratio of the Imports in Kazakhstan in 2012 to that in 2013?
Provide a succinct answer. 0.93. What is the ratio of the Imports of Cameroon in 2012 to that in 2014?
Offer a very short reply. 0.74. What is the ratio of the Imports in Cote d'Ivoire in 2012 to that in 2014?
Make the answer very short. 0.91. What is the ratio of the Imports of Germany in 2012 to that in 2014?
Provide a succinct answer. 0.94. What is the ratio of the Imports in Kazakhstan in 2012 to that in 2014?
Your answer should be compact. 1.1. What is the ratio of the Imports in Cameroon in 2013 to that in 2014?
Your answer should be compact. 0.87. What is the ratio of the Imports of Cote d'Ivoire in 2013 to that in 2014?
Your answer should be very brief. 0.96. What is the ratio of the Imports of Germany in 2013 to that in 2014?
Offer a terse response. 0.96. What is the ratio of the Imports in Kazakhstan in 2013 to that in 2014?
Ensure brevity in your answer.  1.19. What is the difference between the highest and the second highest Imports in Cameroon?
Offer a terse response. 4.39e+11. What is the difference between the highest and the second highest Imports of Cote d'Ivoire?
Your response must be concise. 2.21e+11. What is the difference between the highest and the second highest Imports in Germany?
Offer a very short reply. 3.92e+1. What is the difference between the highest and the second highest Imports of Kazakhstan?
Your answer should be very brief. 3.44e+11. What is the difference between the highest and the lowest Imports in Cameroon?
Ensure brevity in your answer.  1.55e+12. What is the difference between the highest and the lowest Imports in Cote d'Ivoire?
Give a very brief answer. 2.00e+12. What is the difference between the highest and the lowest Imports in Germany?
Provide a short and direct response. 2.43e+11. What is the difference between the highest and the lowest Imports in Kazakhstan?
Your answer should be very brief. 1.41e+12. 